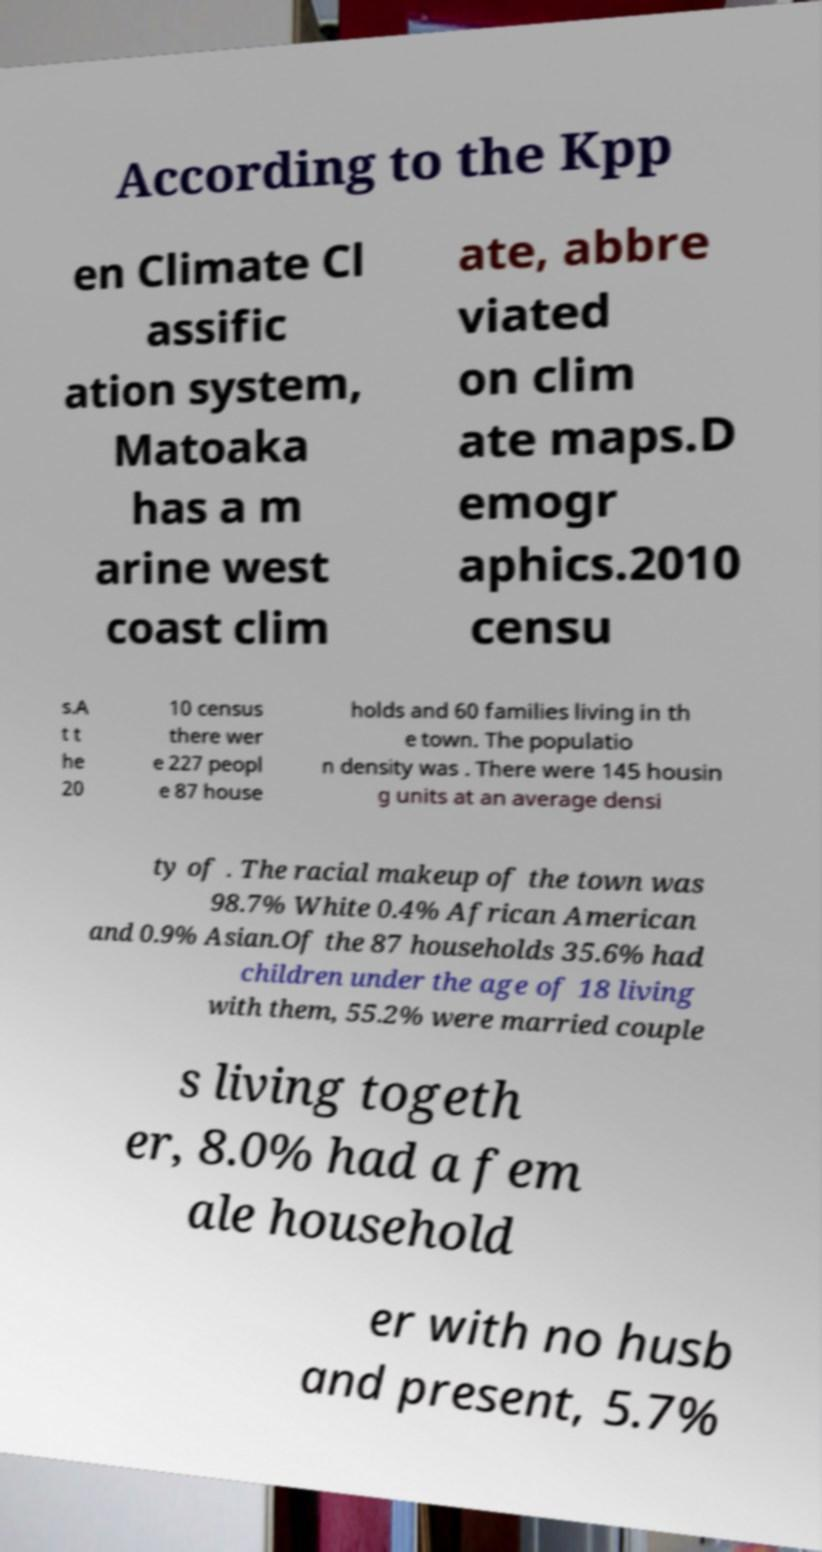Please read and relay the text visible in this image. What does it say? According to the Kpp en Climate Cl assific ation system, Matoaka has a m arine west coast clim ate, abbre viated on clim ate maps.D emogr aphics.2010 censu s.A t t he 20 10 census there wer e 227 peopl e 87 house holds and 60 families living in th e town. The populatio n density was . There were 145 housin g units at an average densi ty of . The racial makeup of the town was 98.7% White 0.4% African American and 0.9% Asian.Of the 87 households 35.6% had children under the age of 18 living with them, 55.2% were married couple s living togeth er, 8.0% had a fem ale household er with no husb and present, 5.7% 